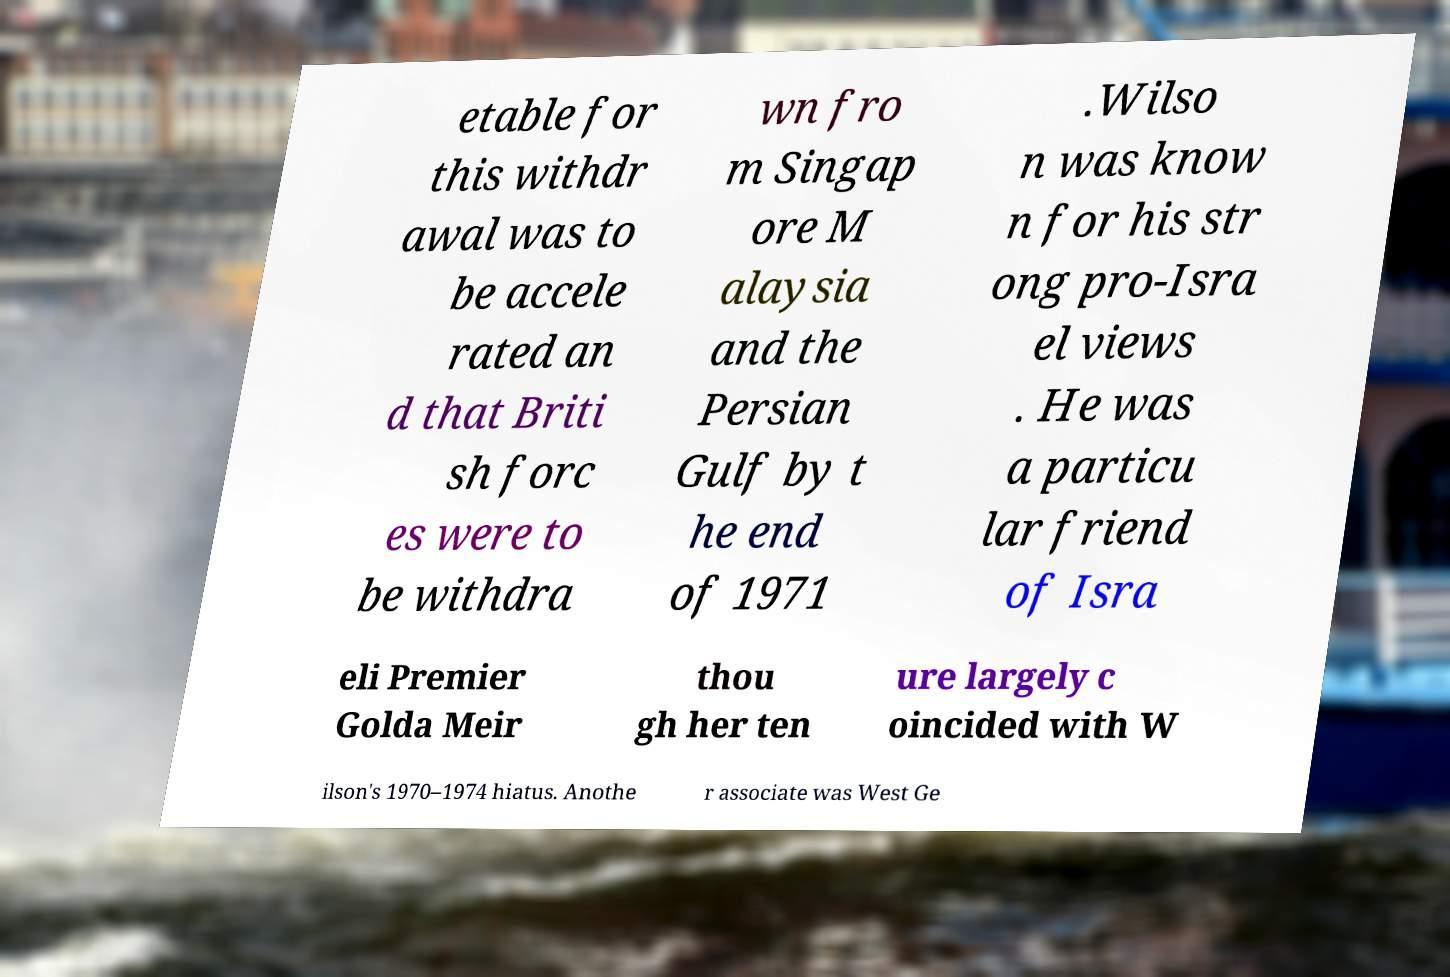Please read and relay the text visible in this image. What does it say? etable for this withdr awal was to be accele rated an d that Briti sh forc es were to be withdra wn fro m Singap ore M alaysia and the Persian Gulf by t he end of 1971 .Wilso n was know n for his str ong pro-Isra el views . He was a particu lar friend of Isra eli Premier Golda Meir thou gh her ten ure largely c oincided with W ilson's 1970–1974 hiatus. Anothe r associate was West Ge 